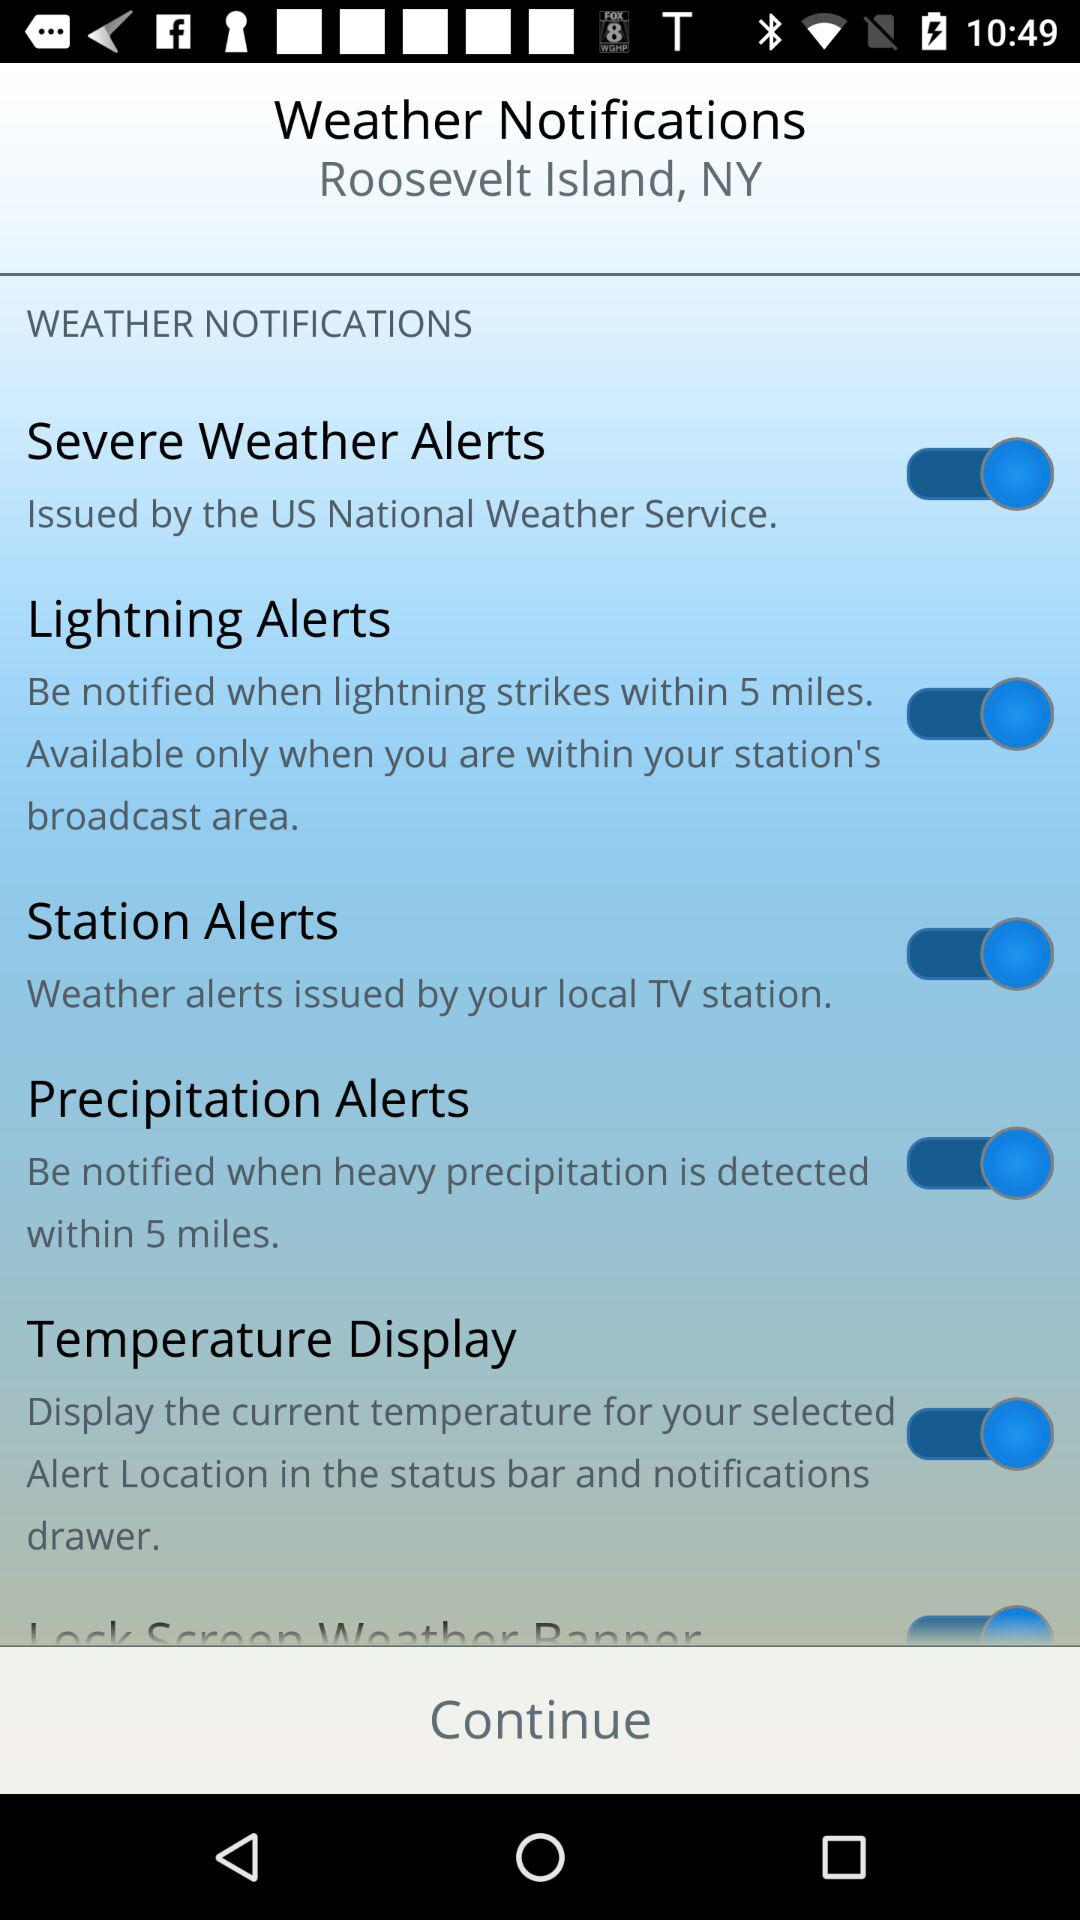Who issues severe weather alerts? Severe weather alerts are issued by the "US National Weather Service". 